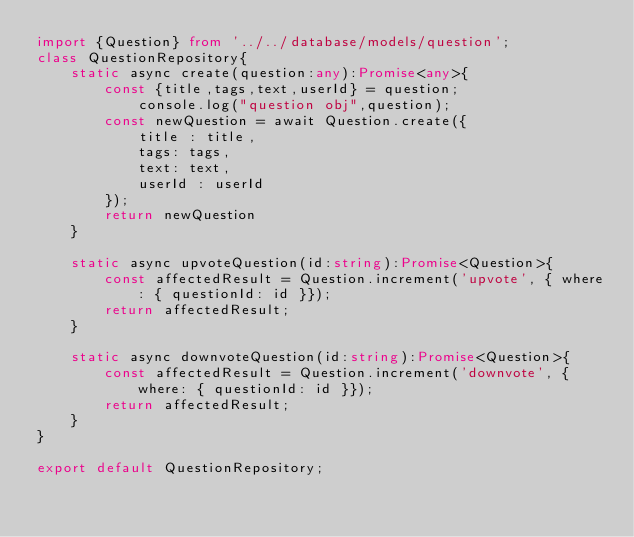Convert code to text. <code><loc_0><loc_0><loc_500><loc_500><_TypeScript_>import {Question} from '../../database/models/question';
class QuestionRepository{
    static async create(question:any):Promise<any>{
        const {title,tags,text,userId} = question;
            console.log("question obj",question);
        const newQuestion = await Question.create({
            title : title,
            tags: tags,
            text: text,
            userId : userId
        });     
        return newQuestion
    }

    static async upvoteQuestion(id:string):Promise<Question>{
        const affectedResult = Question.increment('upvote', { where: { questionId: id }});
        return affectedResult;
    }

    static async downvoteQuestion(id:string):Promise<Question>{
        const affectedResult = Question.increment('downvote', { where: { questionId: id }});
        return affectedResult;
    }
}

export default QuestionRepository;
</code> 